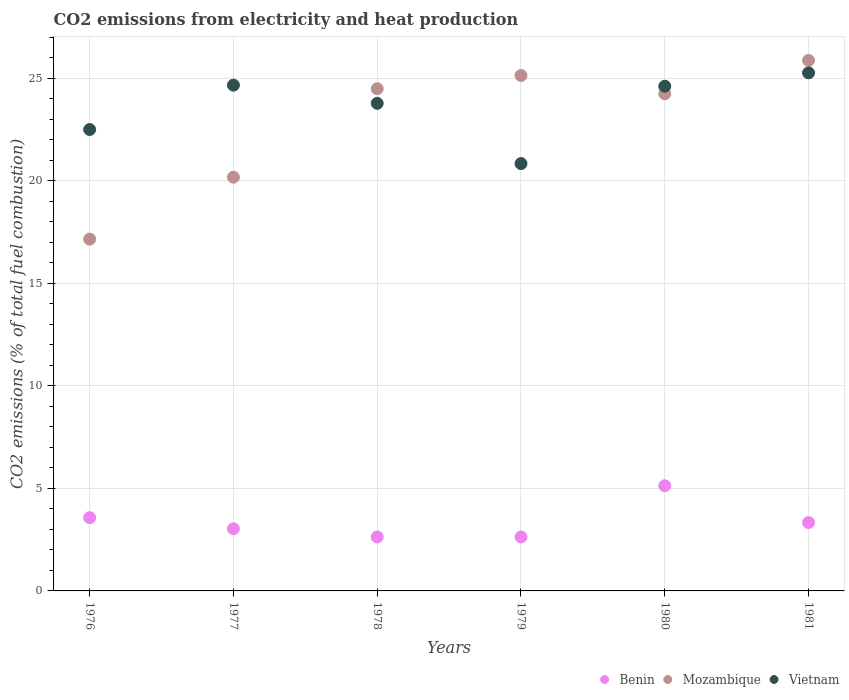What is the amount of CO2 emitted in Mozambique in 1978?
Your answer should be very brief. 24.49. Across all years, what is the maximum amount of CO2 emitted in Mozambique?
Keep it short and to the point. 25.87. Across all years, what is the minimum amount of CO2 emitted in Mozambique?
Your answer should be very brief. 17.15. In which year was the amount of CO2 emitted in Mozambique minimum?
Offer a terse response. 1976. What is the total amount of CO2 emitted in Benin in the graph?
Your answer should be compact. 20.33. What is the difference between the amount of CO2 emitted in Benin in 1976 and that in 1978?
Provide a succinct answer. 0.94. What is the difference between the amount of CO2 emitted in Vietnam in 1978 and the amount of CO2 emitted in Benin in 1977?
Your answer should be compact. 20.75. What is the average amount of CO2 emitted in Benin per year?
Provide a short and direct response. 3.39. In the year 1978, what is the difference between the amount of CO2 emitted in Mozambique and amount of CO2 emitted in Benin?
Offer a terse response. 21.86. In how many years, is the amount of CO2 emitted in Mozambique greater than 6 %?
Provide a short and direct response. 6. What is the ratio of the amount of CO2 emitted in Vietnam in 1977 to that in 1980?
Your answer should be very brief. 1. Is the difference between the amount of CO2 emitted in Mozambique in 1977 and 1979 greater than the difference between the amount of CO2 emitted in Benin in 1977 and 1979?
Keep it short and to the point. No. What is the difference between the highest and the second highest amount of CO2 emitted in Benin?
Offer a very short reply. 1.56. What is the difference between the highest and the lowest amount of CO2 emitted in Benin?
Your answer should be compact. 2.5. In how many years, is the amount of CO2 emitted in Benin greater than the average amount of CO2 emitted in Benin taken over all years?
Your response must be concise. 2. Is the sum of the amount of CO2 emitted in Mozambique in 1978 and 1981 greater than the maximum amount of CO2 emitted in Benin across all years?
Ensure brevity in your answer.  Yes. Does the amount of CO2 emitted in Mozambique monotonically increase over the years?
Provide a short and direct response. No. Is the amount of CO2 emitted in Vietnam strictly less than the amount of CO2 emitted in Benin over the years?
Your answer should be compact. No. How many years are there in the graph?
Give a very brief answer. 6. What is the difference between two consecutive major ticks on the Y-axis?
Provide a short and direct response. 5. Does the graph contain any zero values?
Ensure brevity in your answer.  No. How many legend labels are there?
Your response must be concise. 3. What is the title of the graph?
Provide a short and direct response. CO2 emissions from electricity and heat production. Does "Malta" appear as one of the legend labels in the graph?
Offer a terse response. No. What is the label or title of the Y-axis?
Your response must be concise. CO2 emissions (% of total fuel combustion). What is the CO2 emissions (% of total fuel combustion) in Benin in 1976?
Your answer should be very brief. 3.57. What is the CO2 emissions (% of total fuel combustion) in Mozambique in 1976?
Offer a terse response. 17.15. What is the CO2 emissions (% of total fuel combustion) of Benin in 1977?
Keep it short and to the point. 3.03. What is the CO2 emissions (% of total fuel combustion) in Mozambique in 1977?
Your answer should be very brief. 20.18. What is the CO2 emissions (% of total fuel combustion) of Vietnam in 1977?
Make the answer very short. 24.66. What is the CO2 emissions (% of total fuel combustion) of Benin in 1978?
Provide a short and direct response. 2.63. What is the CO2 emissions (% of total fuel combustion) in Mozambique in 1978?
Make the answer very short. 24.49. What is the CO2 emissions (% of total fuel combustion) in Vietnam in 1978?
Give a very brief answer. 23.78. What is the CO2 emissions (% of total fuel combustion) in Benin in 1979?
Make the answer very short. 2.63. What is the CO2 emissions (% of total fuel combustion) of Mozambique in 1979?
Your response must be concise. 25.13. What is the CO2 emissions (% of total fuel combustion) in Vietnam in 1979?
Provide a succinct answer. 20.84. What is the CO2 emissions (% of total fuel combustion) in Benin in 1980?
Offer a terse response. 5.13. What is the CO2 emissions (% of total fuel combustion) of Mozambique in 1980?
Provide a succinct answer. 24.24. What is the CO2 emissions (% of total fuel combustion) in Vietnam in 1980?
Keep it short and to the point. 24.61. What is the CO2 emissions (% of total fuel combustion) of Benin in 1981?
Your answer should be very brief. 3.33. What is the CO2 emissions (% of total fuel combustion) of Mozambique in 1981?
Keep it short and to the point. 25.87. What is the CO2 emissions (% of total fuel combustion) of Vietnam in 1981?
Your response must be concise. 25.26. Across all years, what is the maximum CO2 emissions (% of total fuel combustion) in Benin?
Offer a very short reply. 5.13. Across all years, what is the maximum CO2 emissions (% of total fuel combustion) in Mozambique?
Your answer should be very brief. 25.87. Across all years, what is the maximum CO2 emissions (% of total fuel combustion) of Vietnam?
Provide a succinct answer. 25.26. Across all years, what is the minimum CO2 emissions (% of total fuel combustion) in Benin?
Offer a very short reply. 2.63. Across all years, what is the minimum CO2 emissions (% of total fuel combustion) in Mozambique?
Your response must be concise. 17.15. Across all years, what is the minimum CO2 emissions (% of total fuel combustion) of Vietnam?
Provide a succinct answer. 20.84. What is the total CO2 emissions (% of total fuel combustion) of Benin in the graph?
Offer a very short reply. 20.33. What is the total CO2 emissions (% of total fuel combustion) in Mozambique in the graph?
Provide a short and direct response. 137.07. What is the total CO2 emissions (% of total fuel combustion) of Vietnam in the graph?
Keep it short and to the point. 141.66. What is the difference between the CO2 emissions (% of total fuel combustion) in Benin in 1976 and that in 1977?
Your response must be concise. 0.54. What is the difference between the CO2 emissions (% of total fuel combustion) in Mozambique in 1976 and that in 1977?
Your answer should be compact. -3.02. What is the difference between the CO2 emissions (% of total fuel combustion) of Vietnam in 1976 and that in 1977?
Provide a short and direct response. -2.16. What is the difference between the CO2 emissions (% of total fuel combustion) of Benin in 1976 and that in 1978?
Your answer should be very brief. 0.94. What is the difference between the CO2 emissions (% of total fuel combustion) in Mozambique in 1976 and that in 1978?
Your answer should be very brief. -7.33. What is the difference between the CO2 emissions (% of total fuel combustion) in Vietnam in 1976 and that in 1978?
Offer a terse response. -1.28. What is the difference between the CO2 emissions (% of total fuel combustion) of Benin in 1976 and that in 1979?
Your response must be concise. 0.94. What is the difference between the CO2 emissions (% of total fuel combustion) of Mozambique in 1976 and that in 1979?
Provide a succinct answer. -7.98. What is the difference between the CO2 emissions (% of total fuel combustion) in Vietnam in 1976 and that in 1979?
Your response must be concise. 1.66. What is the difference between the CO2 emissions (% of total fuel combustion) of Benin in 1976 and that in 1980?
Give a very brief answer. -1.56. What is the difference between the CO2 emissions (% of total fuel combustion) of Mozambique in 1976 and that in 1980?
Offer a terse response. -7.09. What is the difference between the CO2 emissions (% of total fuel combustion) in Vietnam in 1976 and that in 1980?
Your response must be concise. -2.11. What is the difference between the CO2 emissions (% of total fuel combustion) of Benin in 1976 and that in 1981?
Offer a very short reply. 0.24. What is the difference between the CO2 emissions (% of total fuel combustion) of Mozambique in 1976 and that in 1981?
Ensure brevity in your answer.  -8.72. What is the difference between the CO2 emissions (% of total fuel combustion) in Vietnam in 1976 and that in 1981?
Provide a short and direct response. -2.76. What is the difference between the CO2 emissions (% of total fuel combustion) of Benin in 1977 and that in 1978?
Provide a short and direct response. 0.4. What is the difference between the CO2 emissions (% of total fuel combustion) in Mozambique in 1977 and that in 1978?
Provide a succinct answer. -4.31. What is the difference between the CO2 emissions (% of total fuel combustion) of Vietnam in 1977 and that in 1978?
Offer a terse response. 0.89. What is the difference between the CO2 emissions (% of total fuel combustion) in Benin in 1977 and that in 1979?
Make the answer very short. 0.4. What is the difference between the CO2 emissions (% of total fuel combustion) in Mozambique in 1977 and that in 1979?
Offer a terse response. -4.96. What is the difference between the CO2 emissions (% of total fuel combustion) in Vietnam in 1977 and that in 1979?
Your answer should be compact. 3.82. What is the difference between the CO2 emissions (% of total fuel combustion) in Benin in 1977 and that in 1980?
Your answer should be very brief. -2.1. What is the difference between the CO2 emissions (% of total fuel combustion) in Mozambique in 1977 and that in 1980?
Ensure brevity in your answer.  -4.07. What is the difference between the CO2 emissions (% of total fuel combustion) of Vietnam in 1977 and that in 1980?
Provide a succinct answer. 0.05. What is the difference between the CO2 emissions (% of total fuel combustion) of Benin in 1977 and that in 1981?
Give a very brief answer. -0.3. What is the difference between the CO2 emissions (% of total fuel combustion) in Mozambique in 1977 and that in 1981?
Ensure brevity in your answer.  -5.7. What is the difference between the CO2 emissions (% of total fuel combustion) in Vietnam in 1977 and that in 1981?
Make the answer very short. -0.6. What is the difference between the CO2 emissions (% of total fuel combustion) in Mozambique in 1978 and that in 1979?
Your answer should be very brief. -0.64. What is the difference between the CO2 emissions (% of total fuel combustion) in Vietnam in 1978 and that in 1979?
Provide a succinct answer. 2.94. What is the difference between the CO2 emissions (% of total fuel combustion) of Benin in 1978 and that in 1980?
Make the answer very short. -2.5. What is the difference between the CO2 emissions (% of total fuel combustion) of Mozambique in 1978 and that in 1980?
Your answer should be compact. 0.25. What is the difference between the CO2 emissions (% of total fuel combustion) of Vietnam in 1978 and that in 1980?
Make the answer very short. -0.83. What is the difference between the CO2 emissions (% of total fuel combustion) in Benin in 1978 and that in 1981?
Offer a terse response. -0.7. What is the difference between the CO2 emissions (% of total fuel combustion) of Mozambique in 1978 and that in 1981?
Offer a very short reply. -1.38. What is the difference between the CO2 emissions (% of total fuel combustion) of Vietnam in 1978 and that in 1981?
Your answer should be very brief. -1.49. What is the difference between the CO2 emissions (% of total fuel combustion) in Benin in 1979 and that in 1980?
Ensure brevity in your answer.  -2.5. What is the difference between the CO2 emissions (% of total fuel combustion) in Mozambique in 1979 and that in 1980?
Ensure brevity in your answer.  0.89. What is the difference between the CO2 emissions (% of total fuel combustion) in Vietnam in 1979 and that in 1980?
Provide a succinct answer. -3.77. What is the difference between the CO2 emissions (% of total fuel combustion) in Benin in 1979 and that in 1981?
Make the answer very short. -0.7. What is the difference between the CO2 emissions (% of total fuel combustion) in Mozambique in 1979 and that in 1981?
Your answer should be compact. -0.74. What is the difference between the CO2 emissions (% of total fuel combustion) in Vietnam in 1979 and that in 1981?
Provide a short and direct response. -4.42. What is the difference between the CO2 emissions (% of total fuel combustion) in Benin in 1980 and that in 1981?
Your response must be concise. 1.79. What is the difference between the CO2 emissions (% of total fuel combustion) in Mozambique in 1980 and that in 1981?
Your answer should be compact. -1.63. What is the difference between the CO2 emissions (% of total fuel combustion) in Vietnam in 1980 and that in 1981?
Offer a very short reply. -0.65. What is the difference between the CO2 emissions (% of total fuel combustion) of Benin in 1976 and the CO2 emissions (% of total fuel combustion) of Mozambique in 1977?
Offer a very short reply. -16.6. What is the difference between the CO2 emissions (% of total fuel combustion) in Benin in 1976 and the CO2 emissions (% of total fuel combustion) in Vietnam in 1977?
Your answer should be compact. -21.09. What is the difference between the CO2 emissions (% of total fuel combustion) in Mozambique in 1976 and the CO2 emissions (% of total fuel combustion) in Vietnam in 1977?
Keep it short and to the point. -7.51. What is the difference between the CO2 emissions (% of total fuel combustion) of Benin in 1976 and the CO2 emissions (% of total fuel combustion) of Mozambique in 1978?
Keep it short and to the point. -20.92. What is the difference between the CO2 emissions (% of total fuel combustion) in Benin in 1976 and the CO2 emissions (% of total fuel combustion) in Vietnam in 1978?
Offer a very short reply. -20.21. What is the difference between the CO2 emissions (% of total fuel combustion) in Mozambique in 1976 and the CO2 emissions (% of total fuel combustion) in Vietnam in 1978?
Keep it short and to the point. -6.62. What is the difference between the CO2 emissions (% of total fuel combustion) of Benin in 1976 and the CO2 emissions (% of total fuel combustion) of Mozambique in 1979?
Make the answer very short. -21.56. What is the difference between the CO2 emissions (% of total fuel combustion) of Benin in 1976 and the CO2 emissions (% of total fuel combustion) of Vietnam in 1979?
Offer a very short reply. -17.27. What is the difference between the CO2 emissions (% of total fuel combustion) in Mozambique in 1976 and the CO2 emissions (% of total fuel combustion) in Vietnam in 1979?
Offer a terse response. -3.68. What is the difference between the CO2 emissions (% of total fuel combustion) of Benin in 1976 and the CO2 emissions (% of total fuel combustion) of Mozambique in 1980?
Give a very brief answer. -20.67. What is the difference between the CO2 emissions (% of total fuel combustion) of Benin in 1976 and the CO2 emissions (% of total fuel combustion) of Vietnam in 1980?
Your answer should be very brief. -21.04. What is the difference between the CO2 emissions (% of total fuel combustion) of Mozambique in 1976 and the CO2 emissions (% of total fuel combustion) of Vietnam in 1980?
Offer a very short reply. -7.46. What is the difference between the CO2 emissions (% of total fuel combustion) in Benin in 1976 and the CO2 emissions (% of total fuel combustion) in Mozambique in 1981?
Your response must be concise. -22.3. What is the difference between the CO2 emissions (% of total fuel combustion) of Benin in 1976 and the CO2 emissions (% of total fuel combustion) of Vietnam in 1981?
Make the answer very short. -21.69. What is the difference between the CO2 emissions (% of total fuel combustion) in Mozambique in 1976 and the CO2 emissions (% of total fuel combustion) in Vietnam in 1981?
Make the answer very short. -8.11. What is the difference between the CO2 emissions (% of total fuel combustion) of Benin in 1977 and the CO2 emissions (% of total fuel combustion) of Mozambique in 1978?
Your answer should be very brief. -21.46. What is the difference between the CO2 emissions (% of total fuel combustion) in Benin in 1977 and the CO2 emissions (% of total fuel combustion) in Vietnam in 1978?
Offer a terse response. -20.75. What is the difference between the CO2 emissions (% of total fuel combustion) in Mozambique in 1977 and the CO2 emissions (% of total fuel combustion) in Vietnam in 1978?
Offer a terse response. -3.6. What is the difference between the CO2 emissions (% of total fuel combustion) in Benin in 1977 and the CO2 emissions (% of total fuel combustion) in Mozambique in 1979?
Your answer should be compact. -22.1. What is the difference between the CO2 emissions (% of total fuel combustion) of Benin in 1977 and the CO2 emissions (% of total fuel combustion) of Vietnam in 1979?
Keep it short and to the point. -17.81. What is the difference between the CO2 emissions (% of total fuel combustion) of Mozambique in 1977 and the CO2 emissions (% of total fuel combustion) of Vietnam in 1979?
Offer a very short reply. -0.66. What is the difference between the CO2 emissions (% of total fuel combustion) in Benin in 1977 and the CO2 emissions (% of total fuel combustion) in Mozambique in 1980?
Provide a short and direct response. -21.21. What is the difference between the CO2 emissions (% of total fuel combustion) in Benin in 1977 and the CO2 emissions (% of total fuel combustion) in Vietnam in 1980?
Give a very brief answer. -21.58. What is the difference between the CO2 emissions (% of total fuel combustion) of Mozambique in 1977 and the CO2 emissions (% of total fuel combustion) of Vietnam in 1980?
Provide a succinct answer. -4.44. What is the difference between the CO2 emissions (% of total fuel combustion) in Benin in 1977 and the CO2 emissions (% of total fuel combustion) in Mozambique in 1981?
Your answer should be compact. -22.84. What is the difference between the CO2 emissions (% of total fuel combustion) in Benin in 1977 and the CO2 emissions (% of total fuel combustion) in Vietnam in 1981?
Provide a short and direct response. -22.23. What is the difference between the CO2 emissions (% of total fuel combustion) in Mozambique in 1977 and the CO2 emissions (% of total fuel combustion) in Vietnam in 1981?
Your answer should be compact. -5.09. What is the difference between the CO2 emissions (% of total fuel combustion) in Benin in 1978 and the CO2 emissions (% of total fuel combustion) in Mozambique in 1979?
Offer a terse response. -22.5. What is the difference between the CO2 emissions (% of total fuel combustion) in Benin in 1978 and the CO2 emissions (% of total fuel combustion) in Vietnam in 1979?
Provide a succinct answer. -18.21. What is the difference between the CO2 emissions (% of total fuel combustion) in Mozambique in 1978 and the CO2 emissions (% of total fuel combustion) in Vietnam in 1979?
Keep it short and to the point. 3.65. What is the difference between the CO2 emissions (% of total fuel combustion) of Benin in 1978 and the CO2 emissions (% of total fuel combustion) of Mozambique in 1980?
Keep it short and to the point. -21.61. What is the difference between the CO2 emissions (% of total fuel combustion) in Benin in 1978 and the CO2 emissions (% of total fuel combustion) in Vietnam in 1980?
Provide a short and direct response. -21.98. What is the difference between the CO2 emissions (% of total fuel combustion) in Mozambique in 1978 and the CO2 emissions (% of total fuel combustion) in Vietnam in 1980?
Your response must be concise. -0.12. What is the difference between the CO2 emissions (% of total fuel combustion) of Benin in 1978 and the CO2 emissions (% of total fuel combustion) of Mozambique in 1981?
Provide a short and direct response. -23.24. What is the difference between the CO2 emissions (% of total fuel combustion) in Benin in 1978 and the CO2 emissions (% of total fuel combustion) in Vietnam in 1981?
Your response must be concise. -22.63. What is the difference between the CO2 emissions (% of total fuel combustion) of Mozambique in 1978 and the CO2 emissions (% of total fuel combustion) of Vietnam in 1981?
Your answer should be compact. -0.77. What is the difference between the CO2 emissions (% of total fuel combustion) in Benin in 1979 and the CO2 emissions (% of total fuel combustion) in Mozambique in 1980?
Provide a short and direct response. -21.61. What is the difference between the CO2 emissions (% of total fuel combustion) in Benin in 1979 and the CO2 emissions (% of total fuel combustion) in Vietnam in 1980?
Provide a short and direct response. -21.98. What is the difference between the CO2 emissions (% of total fuel combustion) in Mozambique in 1979 and the CO2 emissions (% of total fuel combustion) in Vietnam in 1980?
Your answer should be very brief. 0.52. What is the difference between the CO2 emissions (% of total fuel combustion) in Benin in 1979 and the CO2 emissions (% of total fuel combustion) in Mozambique in 1981?
Keep it short and to the point. -23.24. What is the difference between the CO2 emissions (% of total fuel combustion) in Benin in 1979 and the CO2 emissions (% of total fuel combustion) in Vietnam in 1981?
Your answer should be compact. -22.63. What is the difference between the CO2 emissions (% of total fuel combustion) in Mozambique in 1979 and the CO2 emissions (% of total fuel combustion) in Vietnam in 1981?
Make the answer very short. -0.13. What is the difference between the CO2 emissions (% of total fuel combustion) in Benin in 1980 and the CO2 emissions (% of total fuel combustion) in Mozambique in 1981?
Offer a very short reply. -20.74. What is the difference between the CO2 emissions (% of total fuel combustion) of Benin in 1980 and the CO2 emissions (% of total fuel combustion) of Vietnam in 1981?
Offer a very short reply. -20.14. What is the difference between the CO2 emissions (% of total fuel combustion) of Mozambique in 1980 and the CO2 emissions (% of total fuel combustion) of Vietnam in 1981?
Your answer should be very brief. -1.02. What is the average CO2 emissions (% of total fuel combustion) of Benin per year?
Offer a very short reply. 3.39. What is the average CO2 emissions (% of total fuel combustion) of Mozambique per year?
Ensure brevity in your answer.  22.84. What is the average CO2 emissions (% of total fuel combustion) in Vietnam per year?
Keep it short and to the point. 23.61. In the year 1976, what is the difference between the CO2 emissions (% of total fuel combustion) in Benin and CO2 emissions (% of total fuel combustion) in Mozambique?
Make the answer very short. -13.58. In the year 1976, what is the difference between the CO2 emissions (% of total fuel combustion) of Benin and CO2 emissions (% of total fuel combustion) of Vietnam?
Your response must be concise. -18.93. In the year 1976, what is the difference between the CO2 emissions (% of total fuel combustion) of Mozambique and CO2 emissions (% of total fuel combustion) of Vietnam?
Make the answer very short. -5.35. In the year 1977, what is the difference between the CO2 emissions (% of total fuel combustion) in Benin and CO2 emissions (% of total fuel combustion) in Mozambique?
Offer a very short reply. -17.15. In the year 1977, what is the difference between the CO2 emissions (% of total fuel combustion) in Benin and CO2 emissions (% of total fuel combustion) in Vietnam?
Provide a succinct answer. -21.63. In the year 1977, what is the difference between the CO2 emissions (% of total fuel combustion) in Mozambique and CO2 emissions (% of total fuel combustion) in Vietnam?
Offer a very short reply. -4.49. In the year 1978, what is the difference between the CO2 emissions (% of total fuel combustion) in Benin and CO2 emissions (% of total fuel combustion) in Mozambique?
Provide a succinct answer. -21.86. In the year 1978, what is the difference between the CO2 emissions (% of total fuel combustion) of Benin and CO2 emissions (% of total fuel combustion) of Vietnam?
Provide a short and direct response. -21.15. In the year 1978, what is the difference between the CO2 emissions (% of total fuel combustion) in Mozambique and CO2 emissions (% of total fuel combustion) in Vietnam?
Make the answer very short. 0.71. In the year 1979, what is the difference between the CO2 emissions (% of total fuel combustion) of Benin and CO2 emissions (% of total fuel combustion) of Mozambique?
Give a very brief answer. -22.5. In the year 1979, what is the difference between the CO2 emissions (% of total fuel combustion) of Benin and CO2 emissions (% of total fuel combustion) of Vietnam?
Offer a terse response. -18.21. In the year 1979, what is the difference between the CO2 emissions (% of total fuel combustion) in Mozambique and CO2 emissions (% of total fuel combustion) in Vietnam?
Give a very brief answer. 4.29. In the year 1980, what is the difference between the CO2 emissions (% of total fuel combustion) in Benin and CO2 emissions (% of total fuel combustion) in Mozambique?
Ensure brevity in your answer.  -19.11. In the year 1980, what is the difference between the CO2 emissions (% of total fuel combustion) of Benin and CO2 emissions (% of total fuel combustion) of Vietnam?
Offer a terse response. -19.48. In the year 1980, what is the difference between the CO2 emissions (% of total fuel combustion) in Mozambique and CO2 emissions (% of total fuel combustion) in Vietnam?
Your answer should be very brief. -0.37. In the year 1981, what is the difference between the CO2 emissions (% of total fuel combustion) in Benin and CO2 emissions (% of total fuel combustion) in Mozambique?
Your answer should be very brief. -22.54. In the year 1981, what is the difference between the CO2 emissions (% of total fuel combustion) in Benin and CO2 emissions (% of total fuel combustion) in Vietnam?
Your answer should be very brief. -21.93. In the year 1981, what is the difference between the CO2 emissions (% of total fuel combustion) in Mozambique and CO2 emissions (% of total fuel combustion) in Vietnam?
Offer a terse response. 0.61. What is the ratio of the CO2 emissions (% of total fuel combustion) of Benin in 1976 to that in 1977?
Make the answer very short. 1.18. What is the ratio of the CO2 emissions (% of total fuel combustion) of Mozambique in 1976 to that in 1977?
Make the answer very short. 0.85. What is the ratio of the CO2 emissions (% of total fuel combustion) of Vietnam in 1976 to that in 1977?
Offer a terse response. 0.91. What is the ratio of the CO2 emissions (% of total fuel combustion) of Benin in 1976 to that in 1978?
Provide a succinct answer. 1.36. What is the ratio of the CO2 emissions (% of total fuel combustion) of Mozambique in 1976 to that in 1978?
Ensure brevity in your answer.  0.7. What is the ratio of the CO2 emissions (% of total fuel combustion) in Vietnam in 1976 to that in 1978?
Make the answer very short. 0.95. What is the ratio of the CO2 emissions (% of total fuel combustion) of Benin in 1976 to that in 1979?
Keep it short and to the point. 1.36. What is the ratio of the CO2 emissions (% of total fuel combustion) in Mozambique in 1976 to that in 1979?
Give a very brief answer. 0.68. What is the ratio of the CO2 emissions (% of total fuel combustion) of Vietnam in 1976 to that in 1979?
Provide a succinct answer. 1.08. What is the ratio of the CO2 emissions (% of total fuel combustion) of Benin in 1976 to that in 1980?
Offer a terse response. 0.7. What is the ratio of the CO2 emissions (% of total fuel combustion) in Mozambique in 1976 to that in 1980?
Keep it short and to the point. 0.71. What is the ratio of the CO2 emissions (% of total fuel combustion) in Vietnam in 1976 to that in 1980?
Provide a succinct answer. 0.91. What is the ratio of the CO2 emissions (% of total fuel combustion) of Benin in 1976 to that in 1981?
Make the answer very short. 1.07. What is the ratio of the CO2 emissions (% of total fuel combustion) of Mozambique in 1976 to that in 1981?
Your answer should be compact. 0.66. What is the ratio of the CO2 emissions (% of total fuel combustion) in Vietnam in 1976 to that in 1981?
Provide a short and direct response. 0.89. What is the ratio of the CO2 emissions (% of total fuel combustion) of Benin in 1977 to that in 1978?
Make the answer very short. 1.15. What is the ratio of the CO2 emissions (% of total fuel combustion) of Mozambique in 1977 to that in 1978?
Ensure brevity in your answer.  0.82. What is the ratio of the CO2 emissions (% of total fuel combustion) in Vietnam in 1977 to that in 1978?
Give a very brief answer. 1.04. What is the ratio of the CO2 emissions (% of total fuel combustion) in Benin in 1977 to that in 1979?
Your answer should be compact. 1.15. What is the ratio of the CO2 emissions (% of total fuel combustion) in Mozambique in 1977 to that in 1979?
Offer a very short reply. 0.8. What is the ratio of the CO2 emissions (% of total fuel combustion) of Vietnam in 1977 to that in 1979?
Offer a very short reply. 1.18. What is the ratio of the CO2 emissions (% of total fuel combustion) in Benin in 1977 to that in 1980?
Offer a very short reply. 0.59. What is the ratio of the CO2 emissions (% of total fuel combustion) of Mozambique in 1977 to that in 1980?
Give a very brief answer. 0.83. What is the ratio of the CO2 emissions (% of total fuel combustion) of Vietnam in 1977 to that in 1980?
Provide a short and direct response. 1. What is the ratio of the CO2 emissions (% of total fuel combustion) in Benin in 1977 to that in 1981?
Offer a terse response. 0.91. What is the ratio of the CO2 emissions (% of total fuel combustion) of Mozambique in 1977 to that in 1981?
Provide a succinct answer. 0.78. What is the ratio of the CO2 emissions (% of total fuel combustion) in Vietnam in 1977 to that in 1981?
Give a very brief answer. 0.98. What is the ratio of the CO2 emissions (% of total fuel combustion) of Mozambique in 1978 to that in 1979?
Keep it short and to the point. 0.97. What is the ratio of the CO2 emissions (% of total fuel combustion) in Vietnam in 1978 to that in 1979?
Your answer should be very brief. 1.14. What is the ratio of the CO2 emissions (% of total fuel combustion) of Benin in 1978 to that in 1980?
Offer a terse response. 0.51. What is the ratio of the CO2 emissions (% of total fuel combustion) in Mozambique in 1978 to that in 1980?
Your answer should be compact. 1.01. What is the ratio of the CO2 emissions (% of total fuel combustion) of Vietnam in 1978 to that in 1980?
Provide a short and direct response. 0.97. What is the ratio of the CO2 emissions (% of total fuel combustion) in Benin in 1978 to that in 1981?
Your answer should be very brief. 0.79. What is the ratio of the CO2 emissions (% of total fuel combustion) of Mozambique in 1978 to that in 1981?
Provide a short and direct response. 0.95. What is the ratio of the CO2 emissions (% of total fuel combustion) in Benin in 1979 to that in 1980?
Keep it short and to the point. 0.51. What is the ratio of the CO2 emissions (% of total fuel combustion) in Mozambique in 1979 to that in 1980?
Your answer should be compact. 1.04. What is the ratio of the CO2 emissions (% of total fuel combustion) in Vietnam in 1979 to that in 1980?
Provide a succinct answer. 0.85. What is the ratio of the CO2 emissions (% of total fuel combustion) of Benin in 1979 to that in 1981?
Provide a short and direct response. 0.79. What is the ratio of the CO2 emissions (% of total fuel combustion) of Mozambique in 1979 to that in 1981?
Make the answer very short. 0.97. What is the ratio of the CO2 emissions (% of total fuel combustion) in Vietnam in 1979 to that in 1981?
Make the answer very short. 0.82. What is the ratio of the CO2 emissions (% of total fuel combustion) of Benin in 1980 to that in 1981?
Your answer should be compact. 1.54. What is the ratio of the CO2 emissions (% of total fuel combustion) in Mozambique in 1980 to that in 1981?
Keep it short and to the point. 0.94. What is the ratio of the CO2 emissions (% of total fuel combustion) of Vietnam in 1980 to that in 1981?
Provide a succinct answer. 0.97. What is the difference between the highest and the second highest CO2 emissions (% of total fuel combustion) of Benin?
Provide a succinct answer. 1.56. What is the difference between the highest and the second highest CO2 emissions (% of total fuel combustion) of Mozambique?
Your response must be concise. 0.74. What is the difference between the highest and the second highest CO2 emissions (% of total fuel combustion) in Vietnam?
Make the answer very short. 0.6. What is the difference between the highest and the lowest CO2 emissions (% of total fuel combustion) of Benin?
Keep it short and to the point. 2.5. What is the difference between the highest and the lowest CO2 emissions (% of total fuel combustion) of Mozambique?
Your response must be concise. 8.72. What is the difference between the highest and the lowest CO2 emissions (% of total fuel combustion) of Vietnam?
Offer a very short reply. 4.42. 